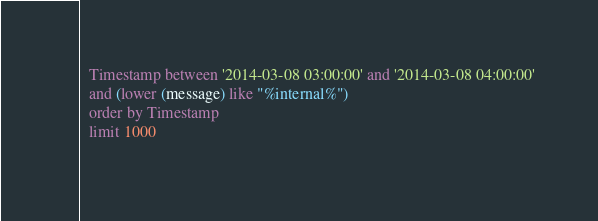Convert code to text. <code><loc_0><loc_0><loc_500><loc_500><_SQL_>  Timestamp between '2014-03-08 03:00:00' and '2014-03-08 04:00:00'
  and (lower (message) like "%internal%")
  order by Timestamp
  limit 1000
 </code> 